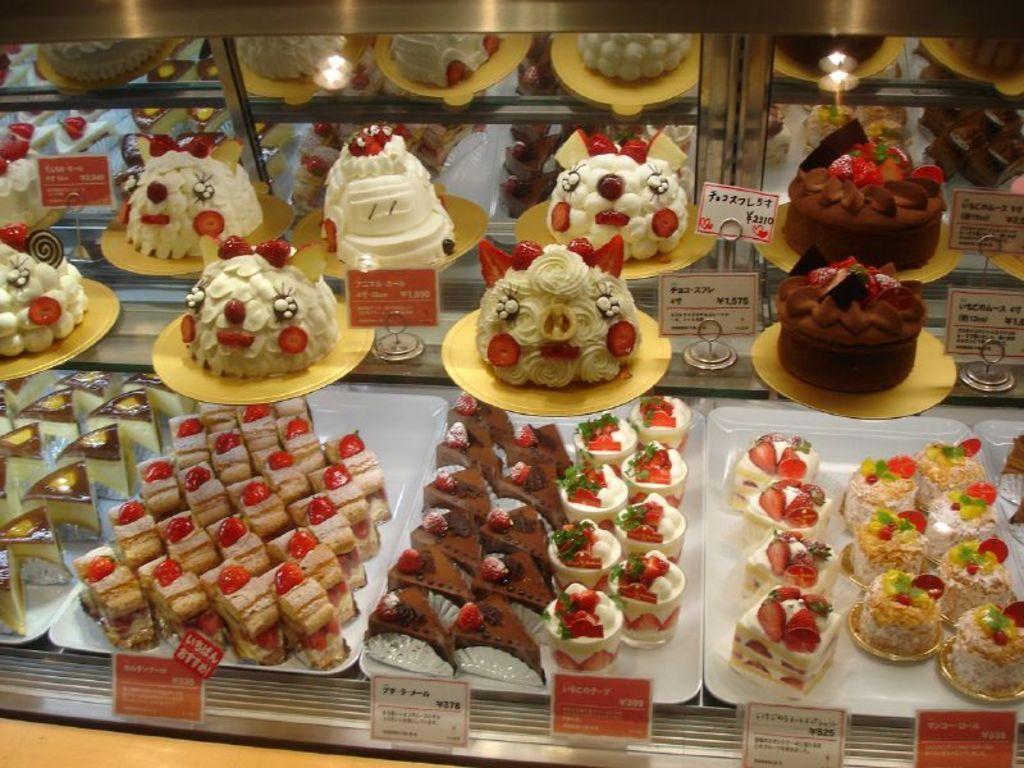Could you give a brief overview of what you see in this image? In the image there are few cakes and pastries kept in display and in front of each item there is a price tag. 